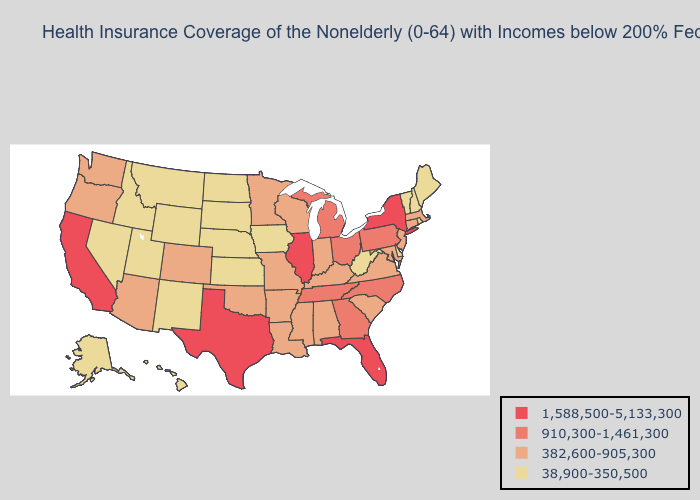Which states have the lowest value in the South?
Concise answer only. Delaware, West Virginia. Which states have the lowest value in the USA?
Be succinct. Alaska, Delaware, Hawaii, Idaho, Iowa, Kansas, Maine, Montana, Nebraska, Nevada, New Hampshire, New Mexico, North Dakota, Rhode Island, South Dakota, Utah, Vermont, West Virginia, Wyoming. Does the first symbol in the legend represent the smallest category?
Keep it brief. No. Name the states that have a value in the range 910,300-1,461,300?
Short answer required. Georgia, Michigan, North Carolina, Ohio, Pennsylvania, Tennessee. Does Washington have a lower value than Vermont?
Write a very short answer. No. Name the states that have a value in the range 1,588,500-5,133,300?
Quick response, please. California, Florida, Illinois, New York, Texas. What is the value of New Hampshire?
Give a very brief answer. 38,900-350,500. Does Ohio have a lower value than Hawaii?
Quick response, please. No. What is the lowest value in states that border Oregon?
Keep it brief. 38,900-350,500. What is the value of New Jersey?
Write a very short answer. 382,600-905,300. How many symbols are there in the legend?
Keep it brief. 4. Among the states that border Massachusetts , which have the lowest value?
Give a very brief answer. New Hampshire, Rhode Island, Vermont. Is the legend a continuous bar?
Give a very brief answer. No. Does Illinois have the highest value in the USA?
Keep it brief. Yes. Name the states that have a value in the range 382,600-905,300?
Quick response, please. Alabama, Arizona, Arkansas, Colorado, Connecticut, Indiana, Kentucky, Louisiana, Maryland, Massachusetts, Minnesota, Mississippi, Missouri, New Jersey, Oklahoma, Oregon, South Carolina, Virginia, Washington, Wisconsin. 